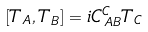Convert formula to latex. <formula><loc_0><loc_0><loc_500><loc_500>\left [ T _ { A } , T _ { B } \right ] = i C _ { \, A B } ^ { C } T _ { C }</formula> 